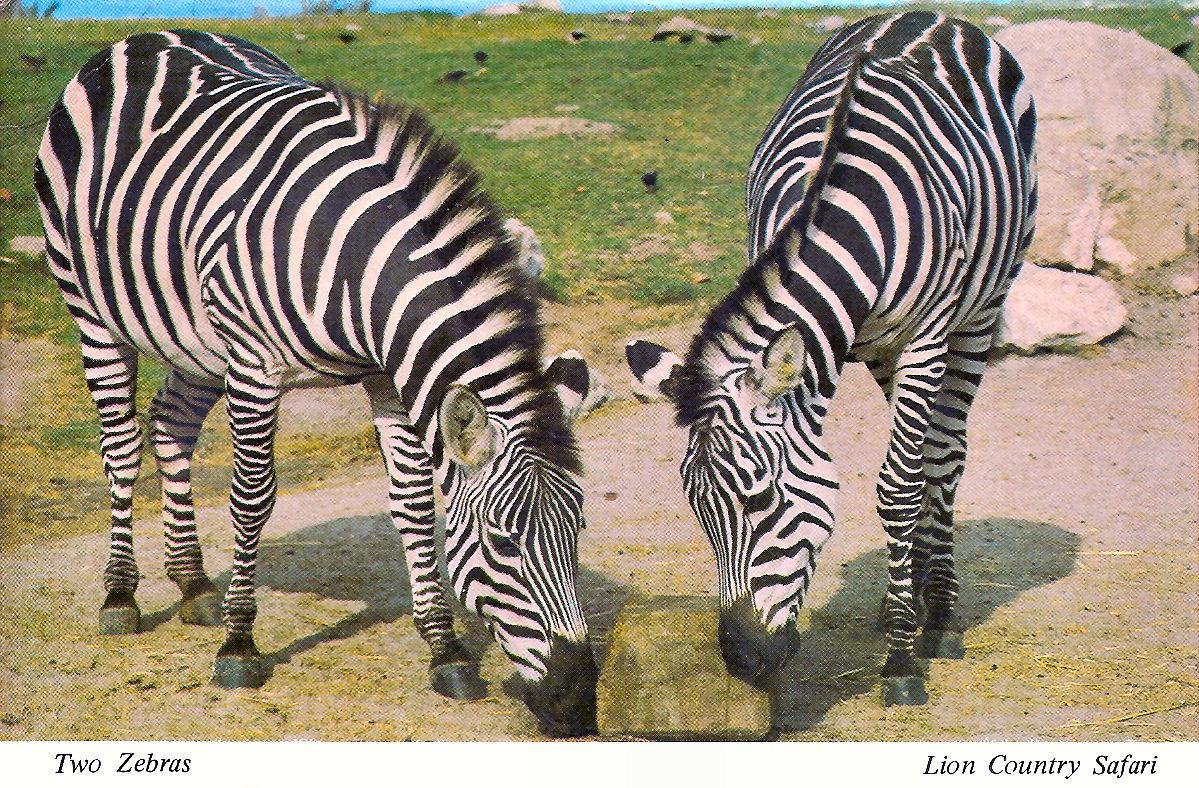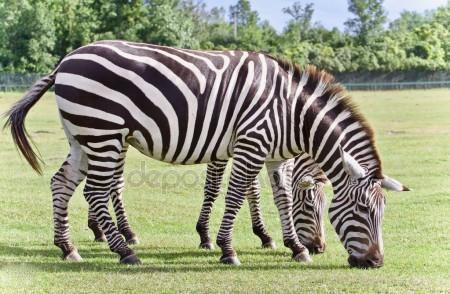The first image is the image on the left, the second image is the image on the right. For the images shown, is this caption "Each image has two zebras and in only one of the images are they looking in the same direction." true? Answer yes or no. Yes. 